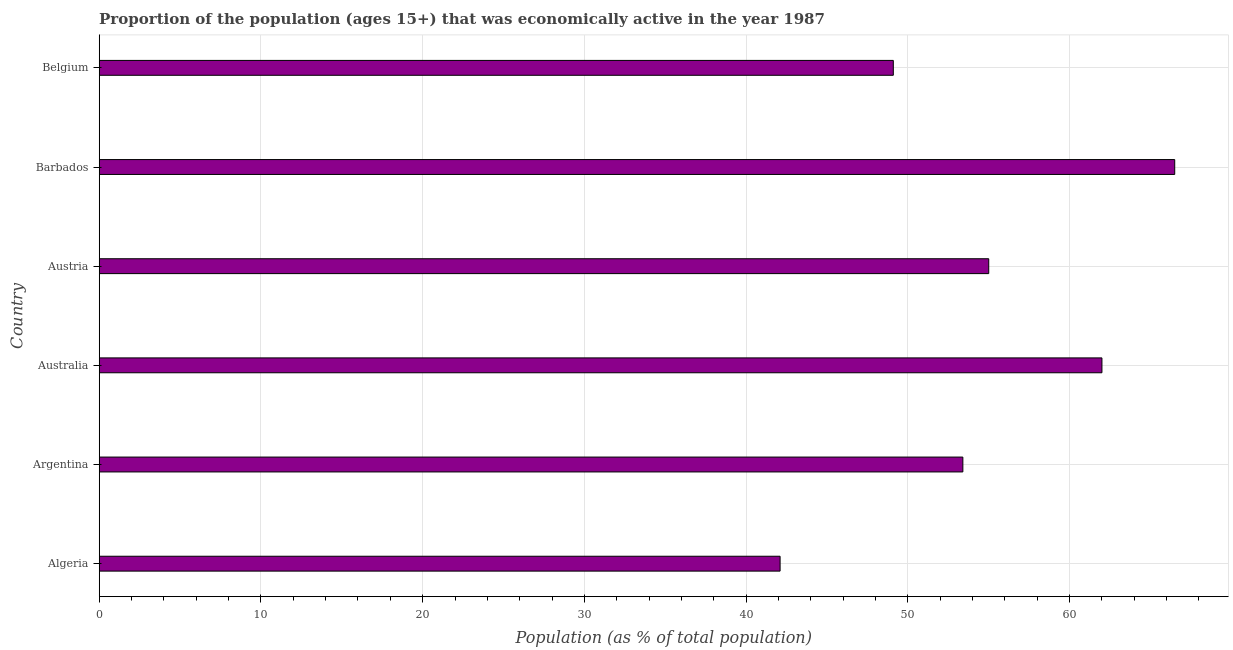Does the graph contain grids?
Your answer should be compact. Yes. What is the title of the graph?
Offer a terse response. Proportion of the population (ages 15+) that was economically active in the year 1987. What is the label or title of the X-axis?
Provide a succinct answer. Population (as % of total population). What is the percentage of economically active population in Argentina?
Offer a very short reply. 53.4. Across all countries, what is the maximum percentage of economically active population?
Make the answer very short. 66.5. Across all countries, what is the minimum percentage of economically active population?
Provide a succinct answer. 42.1. In which country was the percentage of economically active population maximum?
Provide a short and direct response. Barbados. In which country was the percentage of economically active population minimum?
Give a very brief answer. Algeria. What is the sum of the percentage of economically active population?
Your answer should be very brief. 328.1. What is the difference between the percentage of economically active population in Algeria and Belgium?
Your answer should be very brief. -7. What is the average percentage of economically active population per country?
Your answer should be very brief. 54.68. What is the median percentage of economically active population?
Provide a short and direct response. 54.2. What is the ratio of the percentage of economically active population in Australia to that in Barbados?
Ensure brevity in your answer.  0.93. Is the difference between the percentage of economically active population in Argentina and Barbados greater than the difference between any two countries?
Your answer should be very brief. No. Is the sum of the percentage of economically active population in Algeria and Belgium greater than the maximum percentage of economically active population across all countries?
Keep it short and to the point. Yes. What is the difference between the highest and the lowest percentage of economically active population?
Your answer should be very brief. 24.4. In how many countries, is the percentage of economically active population greater than the average percentage of economically active population taken over all countries?
Offer a very short reply. 3. Are all the bars in the graph horizontal?
Your answer should be compact. Yes. What is the difference between two consecutive major ticks on the X-axis?
Provide a succinct answer. 10. Are the values on the major ticks of X-axis written in scientific E-notation?
Make the answer very short. No. What is the Population (as % of total population) in Algeria?
Ensure brevity in your answer.  42.1. What is the Population (as % of total population) in Argentina?
Your answer should be compact. 53.4. What is the Population (as % of total population) in Australia?
Make the answer very short. 62. What is the Population (as % of total population) in Barbados?
Your answer should be very brief. 66.5. What is the Population (as % of total population) in Belgium?
Provide a succinct answer. 49.1. What is the difference between the Population (as % of total population) in Algeria and Australia?
Your response must be concise. -19.9. What is the difference between the Population (as % of total population) in Algeria and Barbados?
Ensure brevity in your answer.  -24.4. What is the difference between the Population (as % of total population) in Algeria and Belgium?
Provide a short and direct response. -7. What is the difference between the Population (as % of total population) in Argentina and Australia?
Your answer should be compact. -8.6. What is the difference between the Population (as % of total population) in Argentina and Austria?
Your answer should be compact. -1.6. What is the difference between the Population (as % of total population) in Argentina and Barbados?
Offer a terse response. -13.1. What is the difference between the Population (as % of total population) in Argentina and Belgium?
Make the answer very short. 4.3. What is the difference between the Population (as % of total population) in Australia and Austria?
Ensure brevity in your answer.  7. What is the difference between the Population (as % of total population) in Australia and Barbados?
Offer a very short reply. -4.5. What is the difference between the Population (as % of total population) in Austria and Barbados?
Give a very brief answer. -11.5. What is the ratio of the Population (as % of total population) in Algeria to that in Argentina?
Offer a terse response. 0.79. What is the ratio of the Population (as % of total population) in Algeria to that in Australia?
Your answer should be compact. 0.68. What is the ratio of the Population (as % of total population) in Algeria to that in Austria?
Provide a short and direct response. 0.77. What is the ratio of the Population (as % of total population) in Algeria to that in Barbados?
Keep it short and to the point. 0.63. What is the ratio of the Population (as % of total population) in Algeria to that in Belgium?
Offer a terse response. 0.86. What is the ratio of the Population (as % of total population) in Argentina to that in Australia?
Offer a terse response. 0.86. What is the ratio of the Population (as % of total population) in Argentina to that in Austria?
Provide a short and direct response. 0.97. What is the ratio of the Population (as % of total population) in Argentina to that in Barbados?
Offer a very short reply. 0.8. What is the ratio of the Population (as % of total population) in Argentina to that in Belgium?
Your answer should be compact. 1.09. What is the ratio of the Population (as % of total population) in Australia to that in Austria?
Your answer should be compact. 1.13. What is the ratio of the Population (as % of total population) in Australia to that in Barbados?
Ensure brevity in your answer.  0.93. What is the ratio of the Population (as % of total population) in Australia to that in Belgium?
Your answer should be compact. 1.26. What is the ratio of the Population (as % of total population) in Austria to that in Barbados?
Give a very brief answer. 0.83. What is the ratio of the Population (as % of total population) in Austria to that in Belgium?
Provide a succinct answer. 1.12. What is the ratio of the Population (as % of total population) in Barbados to that in Belgium?
Provide a short and direct response. 1.35. 